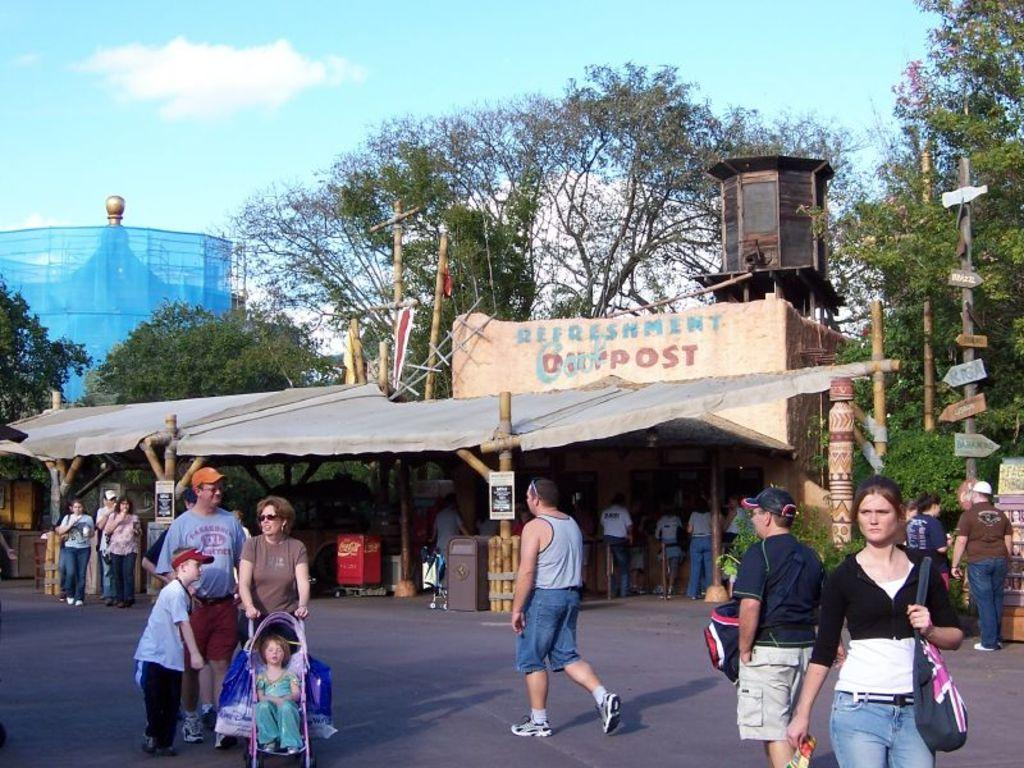What are the people in the image doing? There are people walking and standing in the image. Can you describe the girl in the image? The girl is sitting in a stroller. What can be seen on the pole in the image? There are boards on a pole in the image. What type of structure is present in the image? There is a shed in the image. What is visible in the background of the image? Trees and the sky are visible in the background of the image. How many brothers does the girl in the stroller have in the image? There is no information about the girl's brothers in the image. What direction are the people pointing in the image? There is no indication of people pointing in the image. 